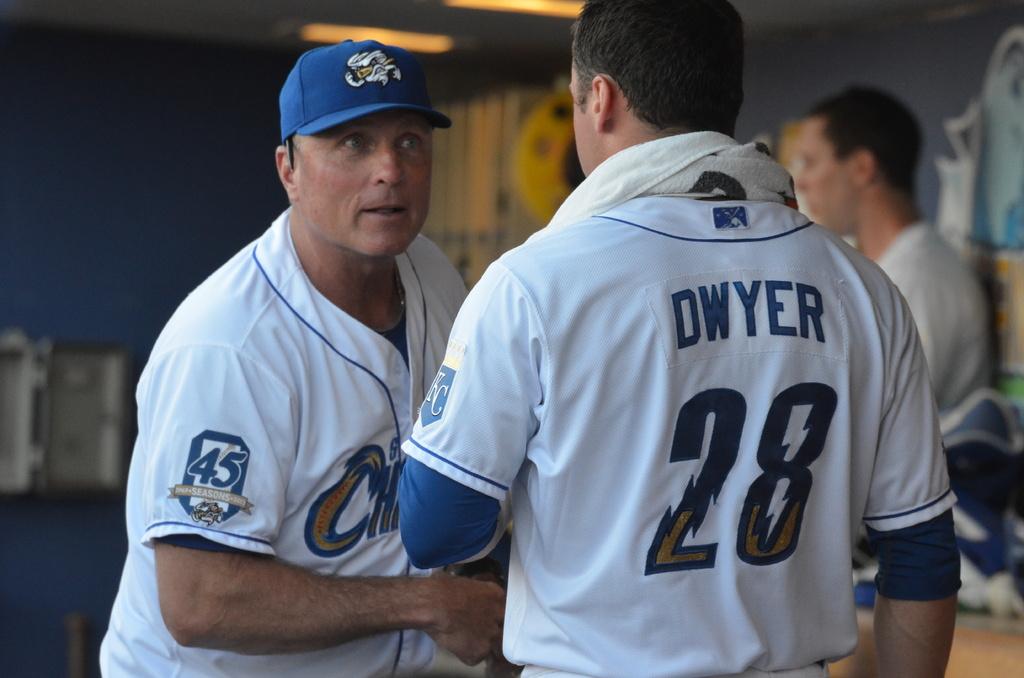What is the last name of player number 28?
Keep it short and to the point. Dwyer. 